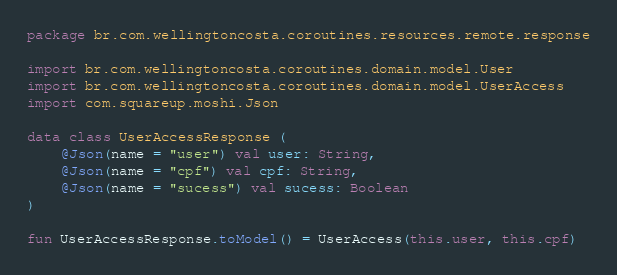Convert code to text. <code><loc_0><loc_0><loc_500><loc_500><_Kotlin_>package br.com.wellingtoncosta.coroutines.resources.remote.response

import br.com.wellingtoncosta.coroutines.domain.model.User
import br.com.wellingtoncosta.coroutines.domain.model.UserAccess
import com.squareup.moshi.Json

data class UserAccessResponse (
    @Json(name = "user") val user: String,
    @Json(name = "cpf") val cpf: String,
    @Json(name = "sucess") val sucess: Boolean
)

fun UserAccessResponse.toModel() = UserAccess(this.user, this.cpf)</code> 